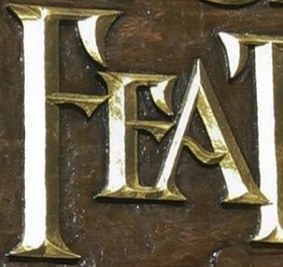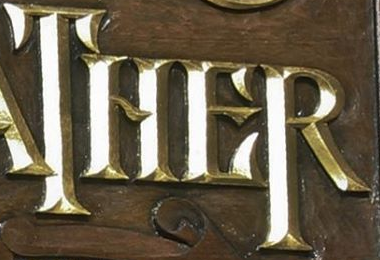Read the text from these images in sequence, separated by a semicolon. FEA; THER 